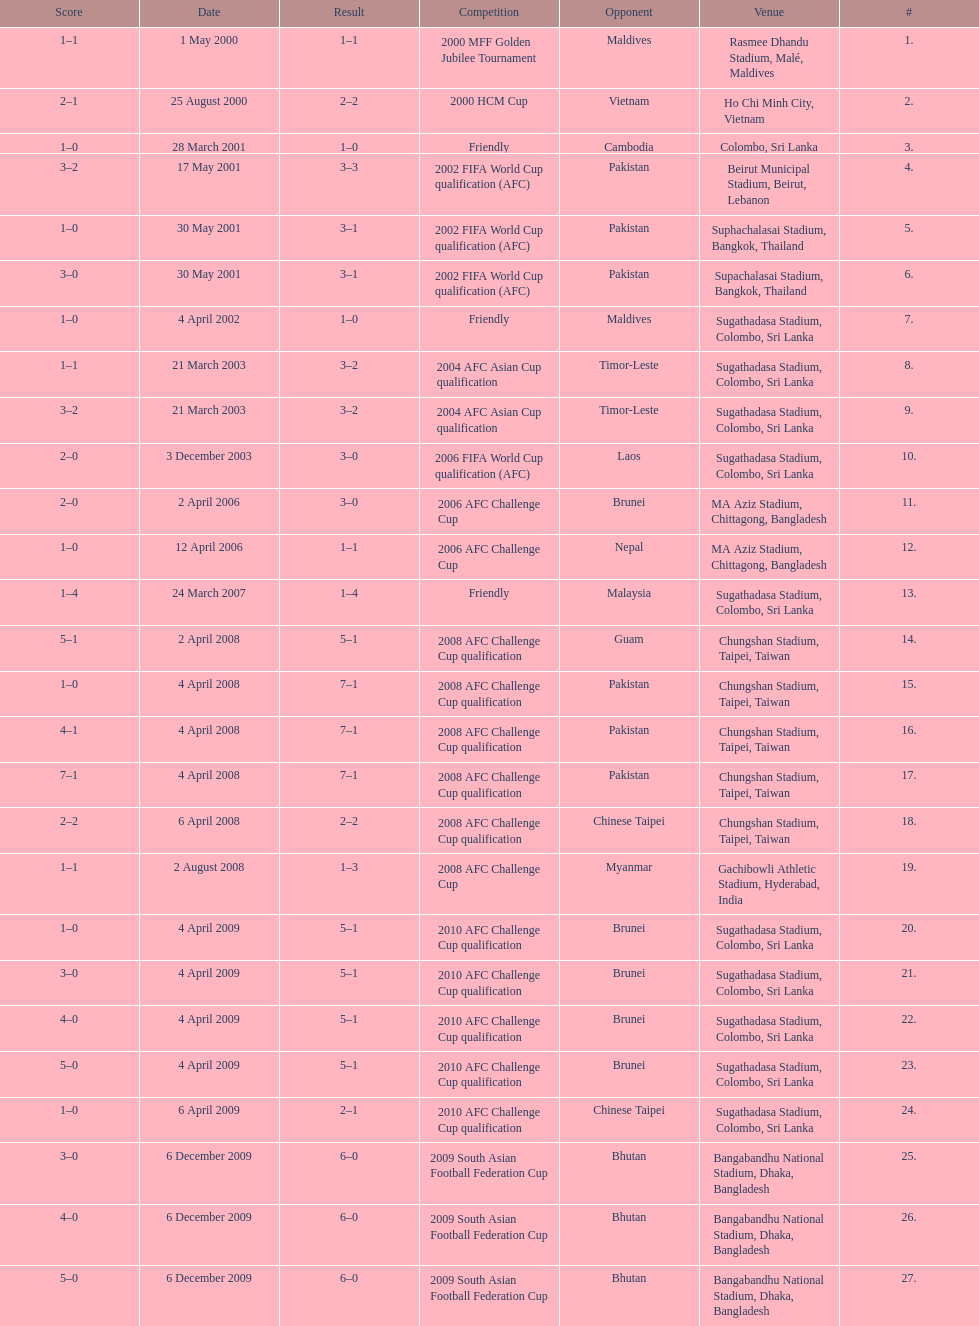What was the total number of goals score in the sri lanka - malaysia game of march 24, 2007? 5. 